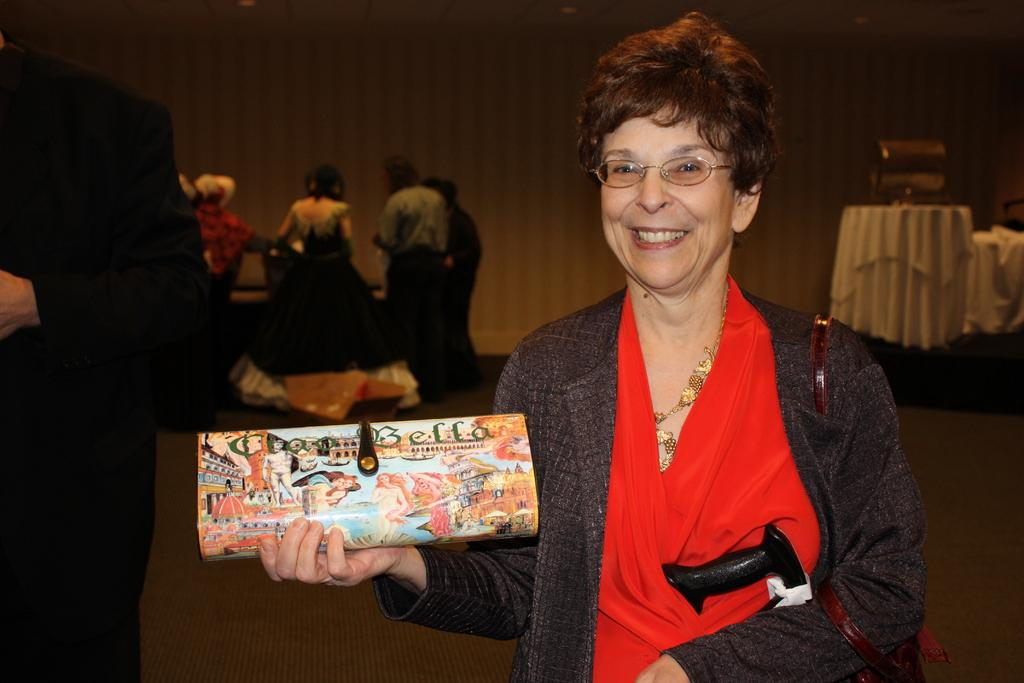Who is present in the image? A woman is in the image. What is the woman holding in her hand? The woman is holding something in her hand, but the specific object is not mentioned in the facts. What is the woman wearing? The woman is wearing a red dress. What is the woman's facial expression? The woman is smiling. Are there any other people visible in the image? Yes, there are people standing on the left side of the image. What rule is being enforced by the cloud in the image? There is no cloud present in the image, and therefore no rule can be enforced by a cloud. 